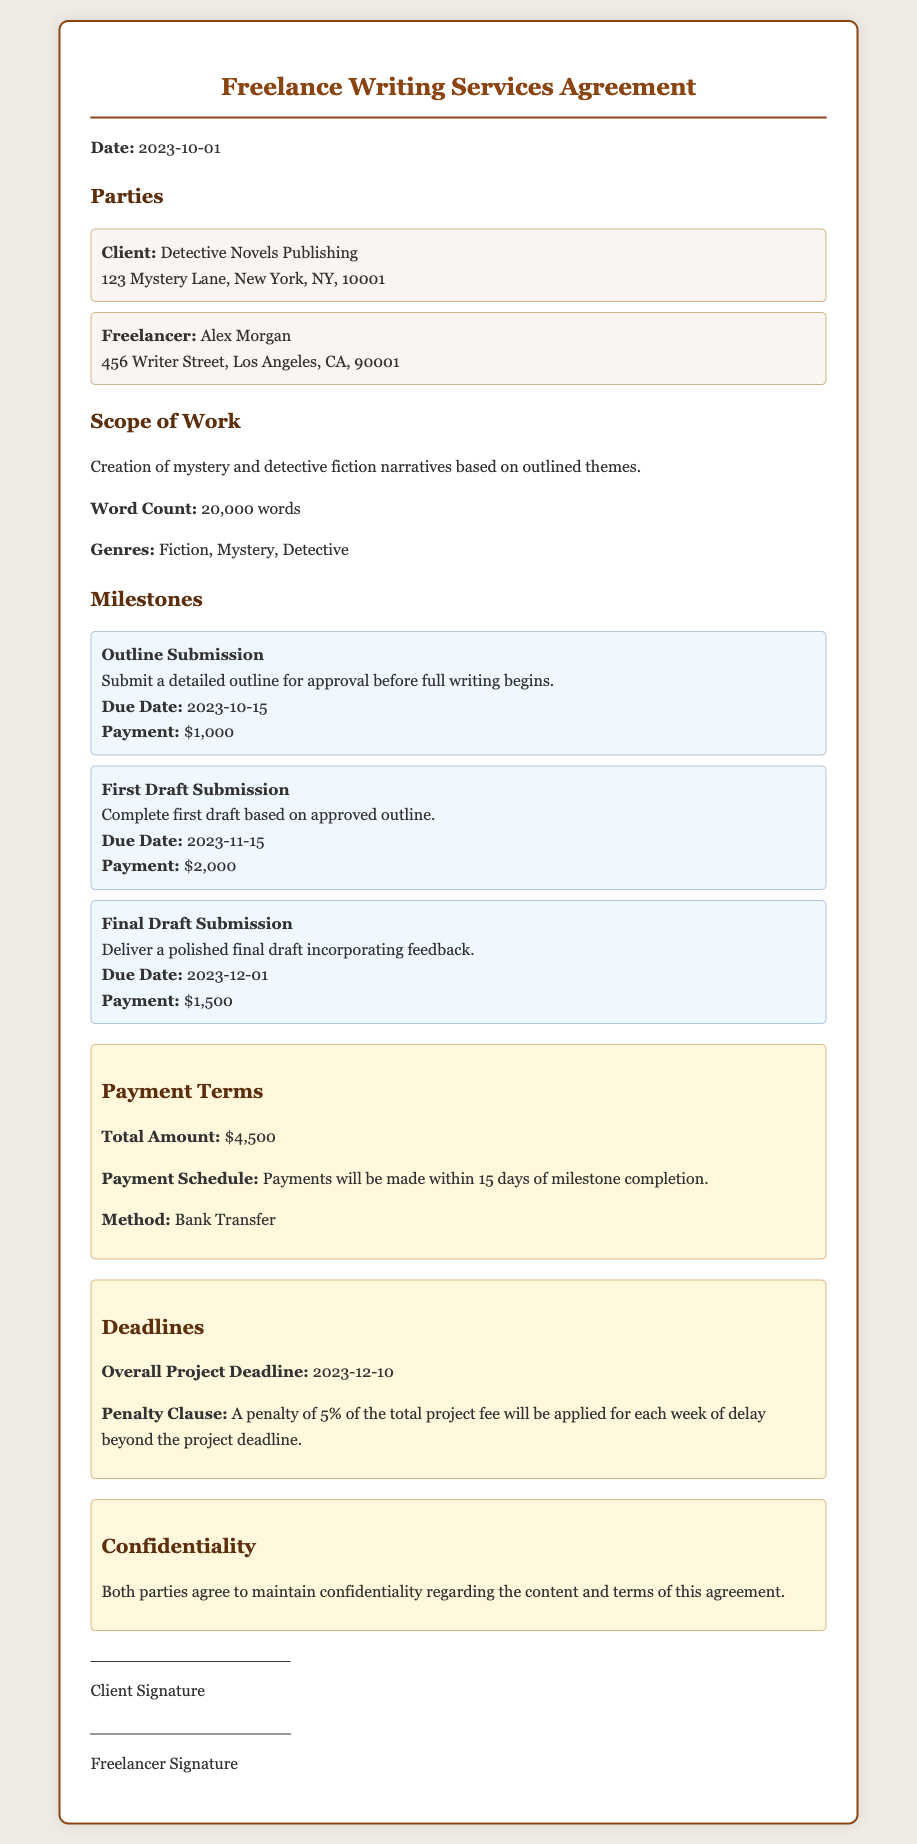what is the total amount for services? The total amount is stated in the payment terms section of the document.
Answer: $4,500 who is the client? The client's name and details are provided in the parties section of the document.
Answer: Detective Novels Publishing what is the due date for the first draft submission? The due date for the first draft is outlined in the milestones section of the document.
Answer: 2023-11-15 what is the penalty for a delay beyond the project deadline? The penalty for delays is specified under the deadlines section of the document.
Answer: 5% who is the freelancer? The freelancer's name is mentioned in the parties section of the document.
Answer: Alex Morgan when is the overall project deadline? The overall project deadline is listed in the deadlines section.
Answer: 2023-12-10 how many words are in the project? The word count is provided in the scope of work section.
Answer: 20,000 words what is the payment method? The payment method is described in the payment terms section of the document.
Answer: Bank Transfer what is required for outline submission? The requirements for outline submission are stated in the milestones section.
Answer: Detailed outline for approval 